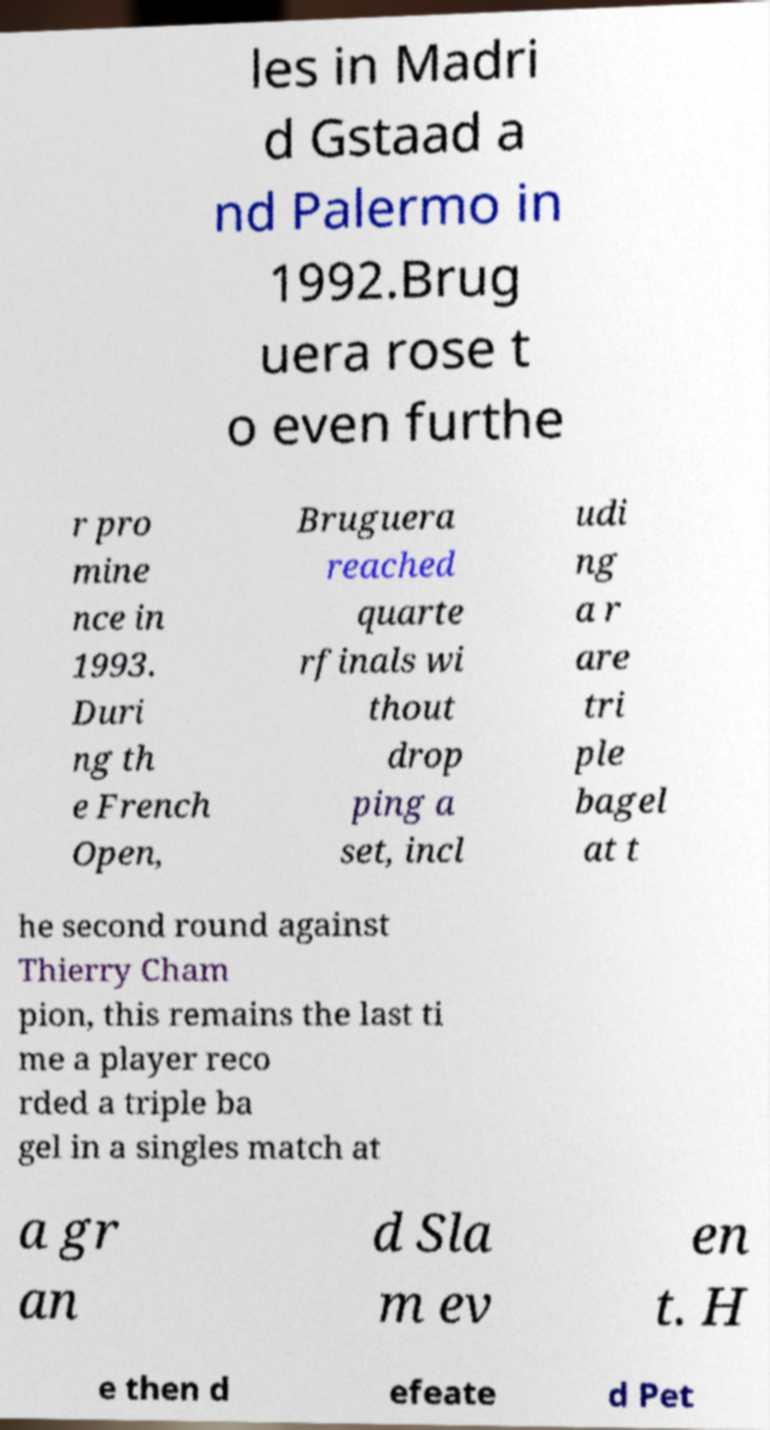For documentation purposes, I need the text within this image transcribed. Could you provide that? les in Madri d Gstaad a nd Palermo in 1992.Brug uera rose t o even furthe r pro mine nce in 1993. Duri ng th e French Open, Bruguera reached quarte rfinals wi thout drop ping a set, incl udi ng a r are tri ple bagel at t he second round against Thierry Cham pion, this remains the last ti me a player reco rded a triple ba gel in a singles match at a gr an d Sla m ev en t. H e then d efeate d Pet 